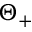Convert formula to latex. <formula><loc_0><loc_0><loc_500><loc_500>\Theta _ { + }</formula> 